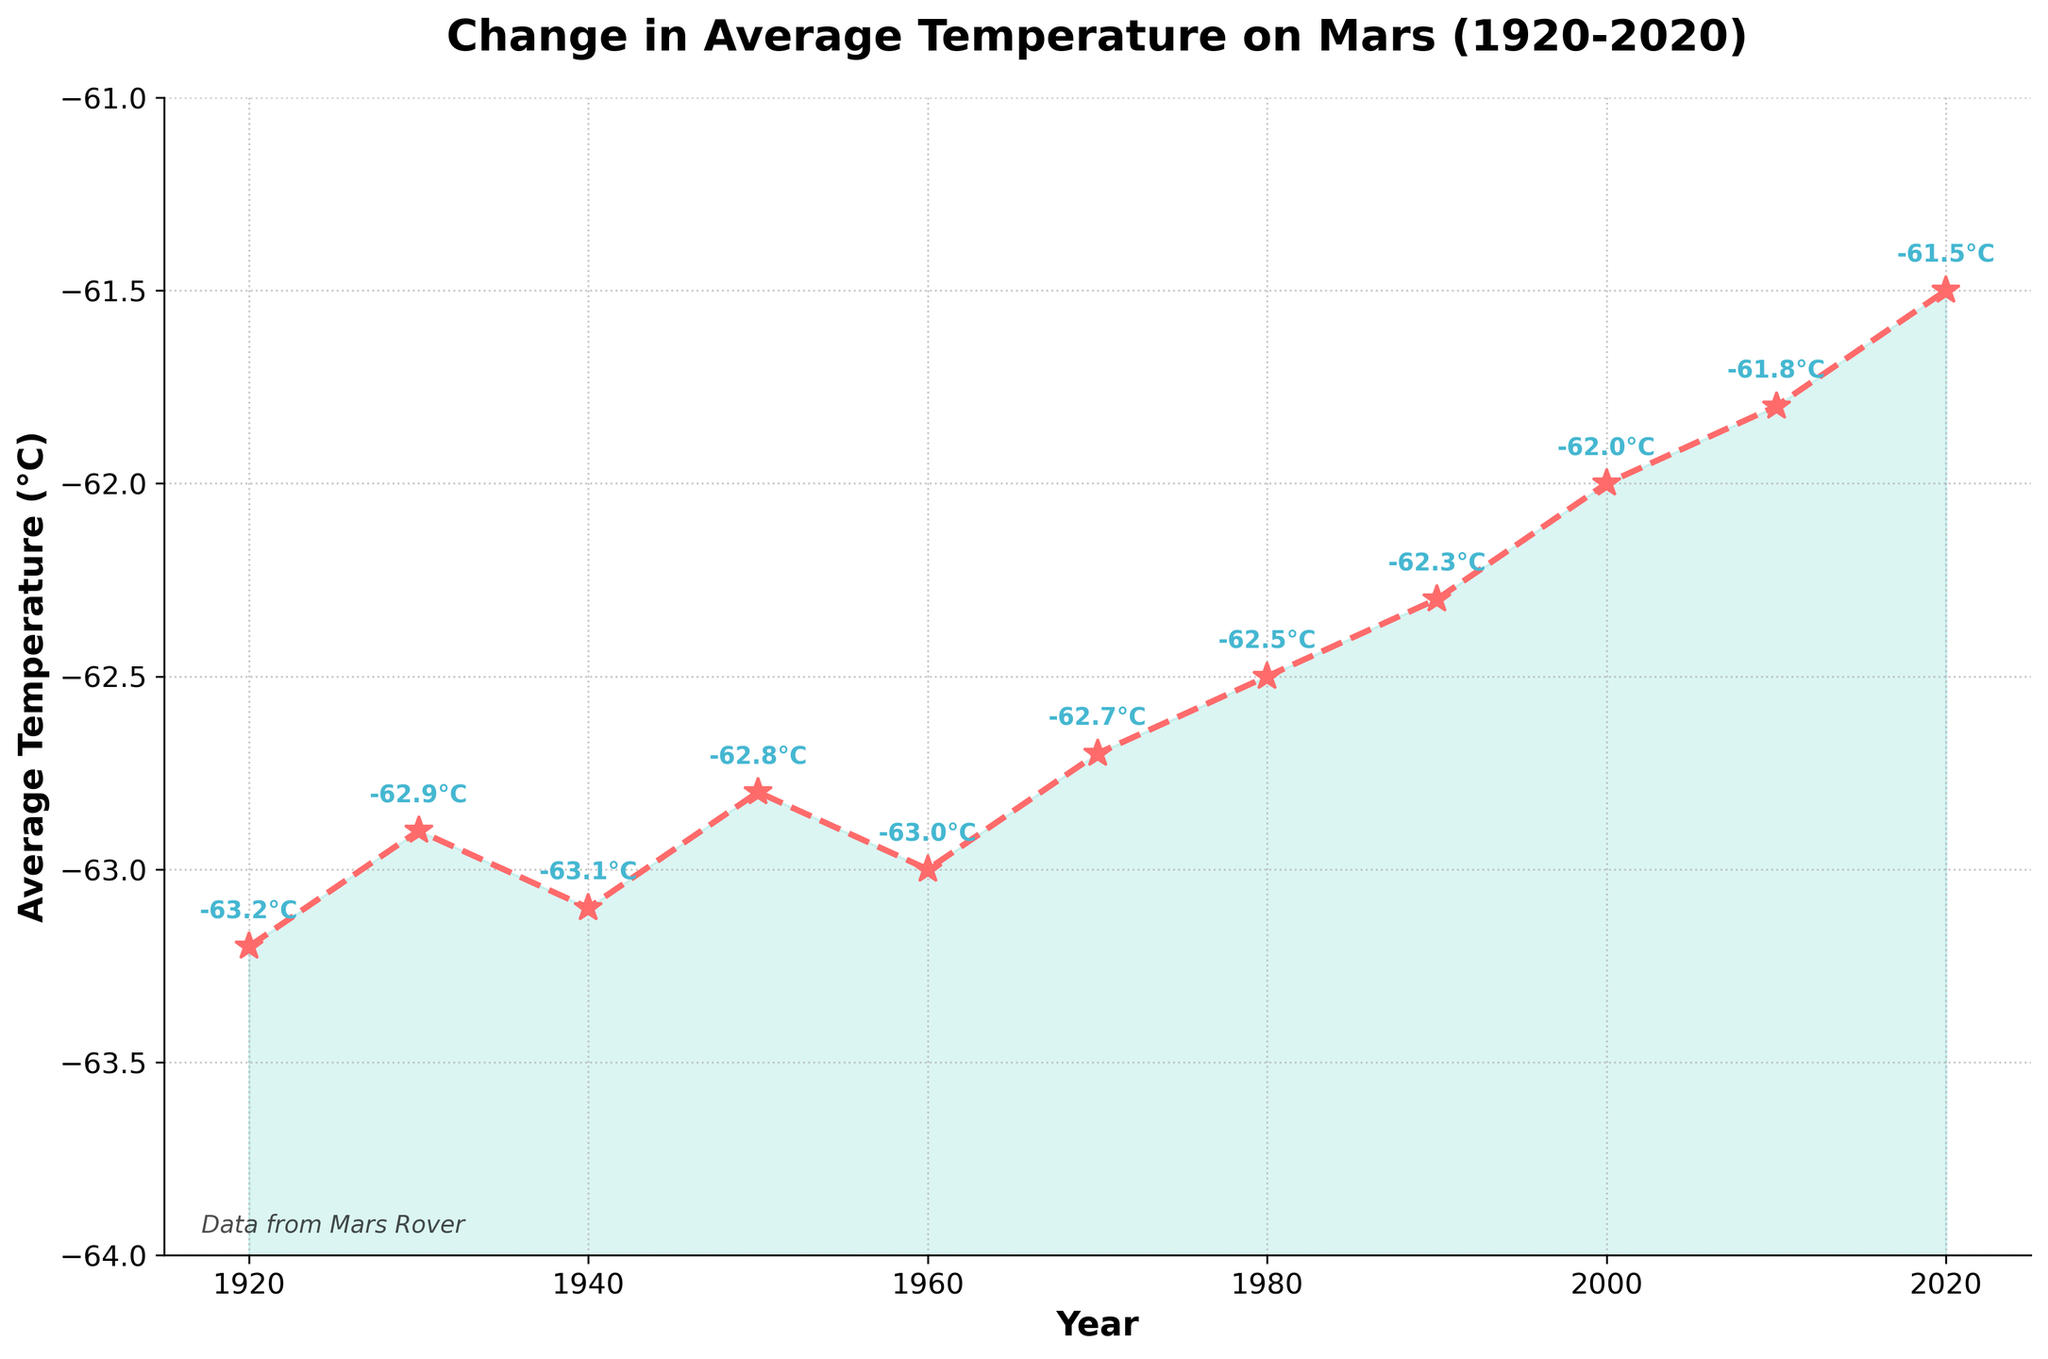What's the average temperature on Mars in 1950 compared to 2020? First, find the temperature values for the years 1950 and 2020 from the chart. The average temperature in 1950 is -62.8°C, while in 2020 it is -61.5°C. Compare these values.
Answer: -62.8°C in 1950, -61.5°C in 2020 By how much has the average temperature on Mars changed from 1920 to 2020? Subtract the average temperature in 1920 (-63.2°C) from that in 2020 (-61.5°C). The calculation is: -61.5 - (-63.2) = 1.7°C.
Answer: 1.7°C Which year experienced the highest average temperature on Mars within the given data range? Identify the highest point on the line plot. The highest average temperature is -61.5°C, which occurs in the year 2020.
Answer: 2020 During which decade did Mars experience the most noticeable increase in average temperature? Examine the slope of the line between each decade. The decade from 1990 to 2000 shows an increase from -62.3°C to -62.0°C, and from 2000 to 2010 it continues to increase to -61.8°C. However, the change between 2010 to 2020 is notable as it increases to -61.5°C.
Answer: 2010-2020 What is the median average temperature on Mars over the given time period? First, list down all the temperatures: -63.2, -62.9, -63.1, -62.8, -63.0, -62.7, -62.5, -62.3, -62.0, -61.8, -61.5. Since there are 11 data points, the median is the 6th value when sorted: -62.7°C.
Answer: -62.7°C How does the trend line show the overall temperature changes on Mars? Observe the line connecting the data points from 1920 to 2020. Notice the overall downward trend indicating an increase in temperature, as temperatures are less negative towards 2020.
Answer: Increase (less negative temperatures) Identify any visual elements that enhance the understanding of the temperature trend on Mars and explain their purpose. Visual elements include the filled area under the line plot (indicating the variance from a fixed temperature), star markers at data points for emphasis, colored lines, and labels of each temperature. These elements highlight the trend, key data points, and reinforce major temperature changes over time.
Answer: Filled area, star markers, colored lines, labels Is there any point in time where the average temperature has decreased from one decade to the next? Check the direction of the line plot between each decade. From 1940 (-63.1°C) to 1950 (-62.8°C), the temperature increased. No decade shows a decrease in this dataset.
Answer: No What was the average temperature on Mars during the 1940s? For the year 1940, refer to the temperature value from the chart, which is indicated as -63.1°C.
Answer: -63.1°C Based on the color-coded regions, what general trend in temperature can we conclude about Mars from this chart? The filled green region underneath the red line visually emphasizes that as the years progress, the average temperatures become warmer (less negative), indicating a warming trend on Mars.
Answer: Warming trend 